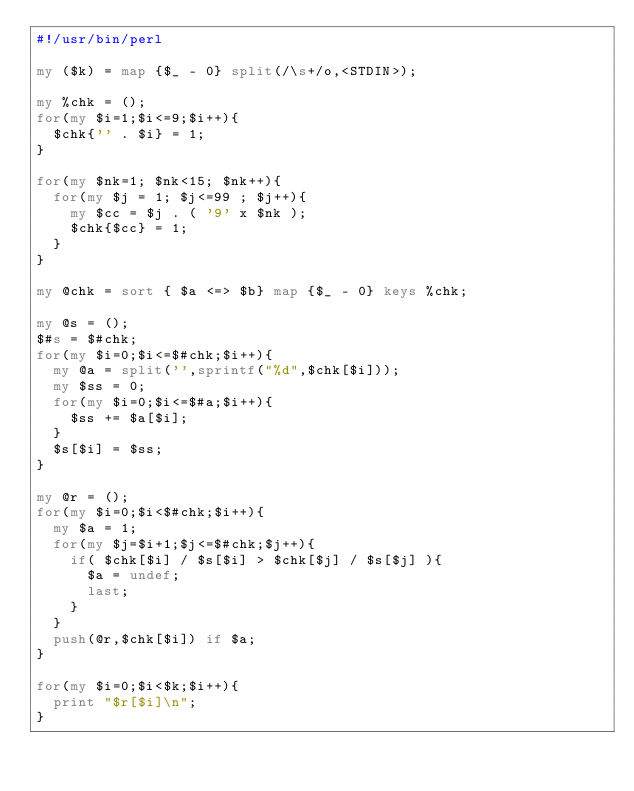Convert code to text. <code><loc_0><loc_0><loc_500><loc_500><_Perl_>#!/usr/bin/perl

my ($k) = map {$_ - 0} split(/\s+/o,<STDIN>);

my %chk = ();
for(my $i=1;$i<=9;$i++){
  $chk{'' . $i} = 1;
}

for(my $nk=1; $nk<15; $nk++){
  for(my $j = 1; $j<=99 ; $j++){
    my $cc = $j . ( '9' x $nk );
    $chk{$cc} = 1;
  }
}

my @chk = sort { $a <=> $b} map {$_ - 0} keys %chk;

my @s = ();
$#s = $#chk;
for(my $i=0;$i<=$#chk;$i++){
  my @a = split('',sprintf("%d",$chk[$i]));
  my $ss = 0;
  for(my $i=0;$i<=$#a;$i++){
    $ss += $a[$i];
  }
  $s[$i] = $ss;
}

my @r = ();
for(my $i=0;$i<$#chk;$i++){
  my $a = 1;
  for(my $j=$i+1;$j<=$#chk;$j++){
    if( $chk[$i] / $s[$i] > $chk[$j] / $s[$j] ){
      $a = undef;
      last;
    }
  }
  push(@r,$chk[$i]) if $a;
}

for(my $i=0;$i<$k;$i++){
  print "$r[$i]\n";
}

</code> 